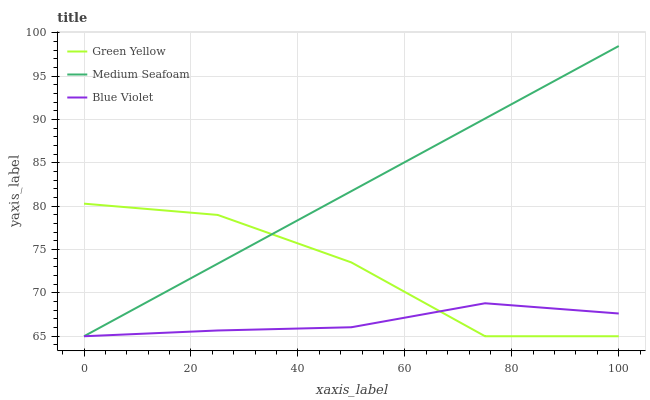Does Blue Violet have the minimum area under the curve?
Answer yes or no. Yes. Does Medium Seafoam have the maximum area under the curve?
Answer yes or no. Yes. Does Medium Seafoam have the minimum area under the curve?
Answer yes or no. No. Does Blue Violet have the maximum area under the curve?
Answer yes or no. No. Is Medium Seafoam the smoothest?
Answer yes or no. Yes. Is Green Yellow the roughest?
Answer yes or no. Yes. Is Blue Violet the smoothest?
Answer yes or no. No. Is Blue Violet the roughest?
Answer yes or no. No. Does Medium Seafoam have the highest value?
Answer yes or no. Yes. Does Blue Violet have the highest value?
Answer yes or no. No. Does Medium Seafoam intersect Green Yellow?
Answer yes or no. Yes. Is Medium Seafoam less than Green Yellow?
Answer yes or no. No. Is Medium Seafoam greater than Green Yellow?
Answer yes or no. No. 